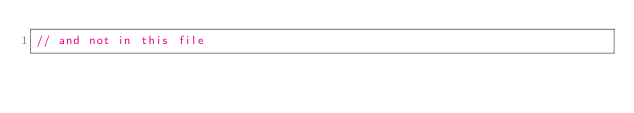Convert code to text. <code><loc_0><loc_0><loc_500><loc_500><_C++_>// and not in this file
</code> 